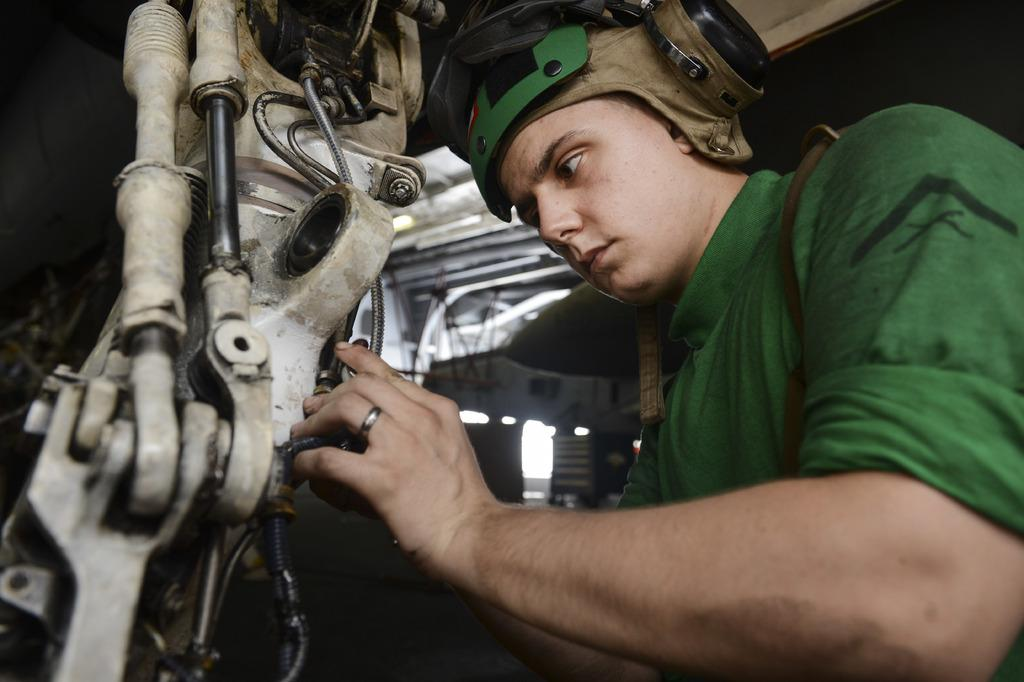What is the main subject of the image? There is a human in the image. What is the human wearing? The human is wearing a green dress. What is the human holding in the image? The human is holding a machine. What other objects can be seen in the image? There are rods and pipes visible in the image. What type of cheese is being used to care for the apple in the image? There is no apple or cheese present in the image. 